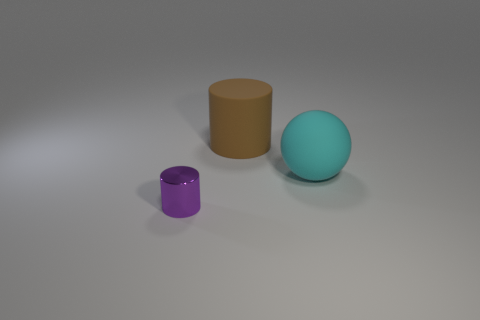Add 3 gray cylinders. How many objects exist? 6 Subtract all balls. How many objects are left? 2 Add 3 big matte objects. How many big matte objects are left? 5 Add 2 large gray metallic blocks. How many large gray metallic blocks exist? 2 Subtract 0 blue spheres. How many objects are left? 3 Subtract all large gray shiny blocks. Subtract all small things. How many objects are left? 2 